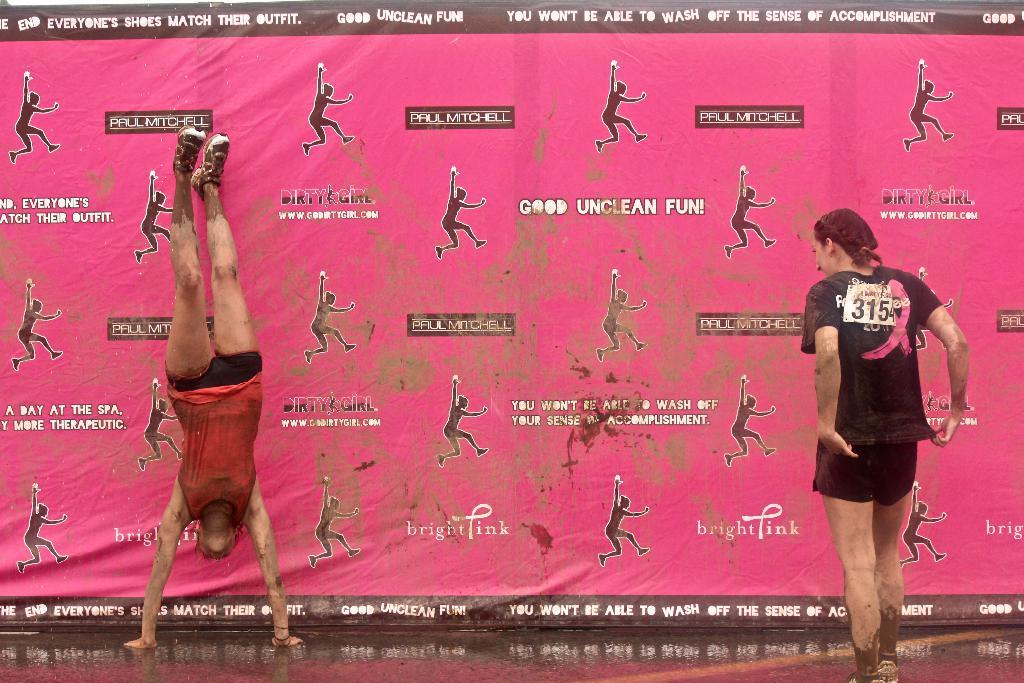What is the position of the person in the image? There is a person upside down in the image. What is the woman in the image doing? There is a woman standing on the floor in the image. What can be seen in the background of the image? There is a banner in the background of the image. What is depicted on the banner? The banner has images of people and some text. What type of cookware is the person using to cook in the image? There is no cookware or cooking activity present in the image. Is there a volcano visible in the background of the image? No, there is no volcano present in the image; only a banner with images of people and text is visible. 